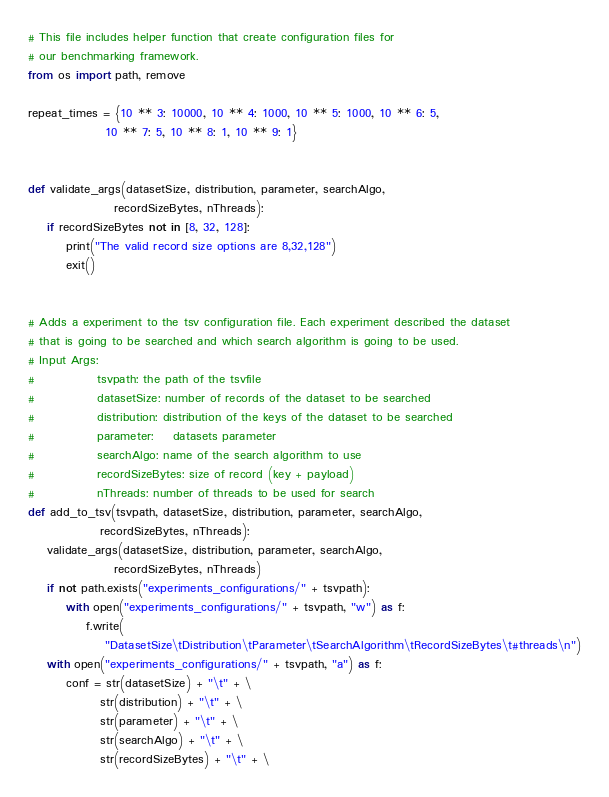<code> <loc_0><loc_0><loc_500><loc_500><_Python_># This file includes helper function that create configuration files for
# our benchmarking framework.
from os import path, remove

repeat_times = {10 ** 3: 10000, 10 ** 4: 1000, 10 ** 5: 1000, 10 ** 6: 5,
                10 ** 7: 5, 10 ** 8: 1, 10 ** 9: 1}


def validate_args(datasetSize, distribution, parameter, searchAlgo,
                  recordSizeBytes, nThreads):
    if recordSizeBytes not in [8, 32, 128]:
        print("The valid record size options are 8,32,128")
        exit()


# Adds a experiment to the tsv configuration file. Each experiment described the dataset
# that is going to be searched and which search algorithm is going to be used.
# Input Args:
#             tsvpath: the path of the tsvfile
#             datasetSize: number of records of the dataset to be searched
#             distribution: distribution of the keys of the dataset to be searched
#             parameter:    datasets parameter
#             searchAlgo: name of the search algorithm to use
#             recordSizeBytes: size of record (key + payload)
#             nThreads: number of threads to be used for search
def add_to_tsv(tsvpath, datasetSize, distribution, parameter, searchAlgo,
               recordSizeBytes, nThreads):
    validate_args(datasetSize, distribution, parameter, searchAlgo,
                  recordSizeBytes, nThreads)
    if not path.exists("experiments_configurations/" + tsvpath):
        with open("experiments_configurations/" + tsvpath, "w") as f:
            f.write(
                "DatasetSize\tDistribution\tParameter\tSearchAlgorithm\tRecordSizeBytes\t#threads\n")
    with open("experiments_configurations/" + tsvpath, "a") as f:
        conf = str(datasetSize) + "\t" + \
               str(distribution) + "\t" + \
               str(parameter) + "\t" + \
               str(searchAlgo) + "\t" + \
               str(recordSizeBytes) + "\t" + \</code> 